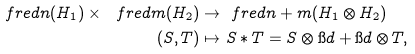Convert formula to latex. <formula><loc_0><loc_0><loc_500><loc_500>\ f r e d { n } ( H _ { 1 } ) \times \ f r e d { m } ( H _ { 2 } ) & \to \ f r e d { n + m } ( H _ { 1 } \otimes H _ { 2 } ) \\ ( S , T ) & \mapsto S \ast T = S \otimes \i d + \i d \otimes T ,</formula> 